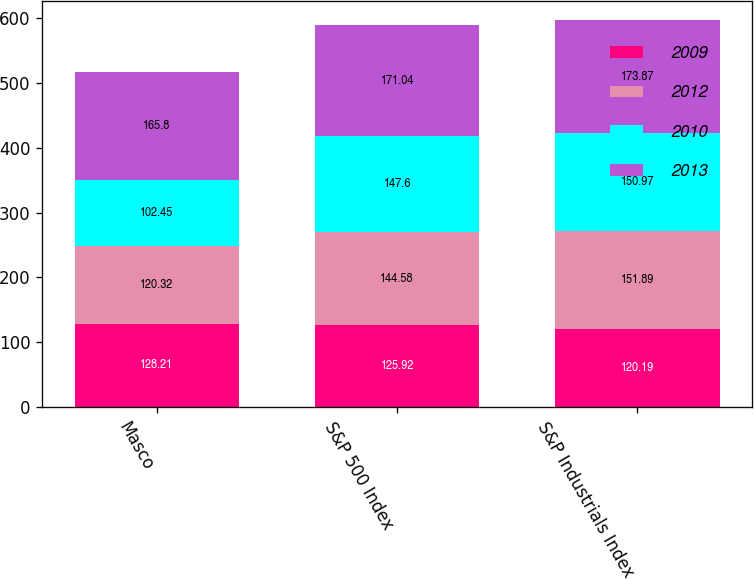Convert chart. <chart><loc_0><loc_0><loc_500><loc_500><stacked_bar_chart><ecel><fcel>Masco<fcel>S&P 500 Index<fcel>S&P Industrials Index<nl><fcel>2009<fcel>128.21<fcel>125.92<fcel>120.19<nl><fcel>2012<fcel>120.32<fcel>144.58<fcel>151.89<nl><fcel>2010<fcel>102.45<fcel>147.6<fcel>150.97<nl><fcel>2013<fcel>165.8<fcel>171.04<fcel>173.87<nl></chart> 